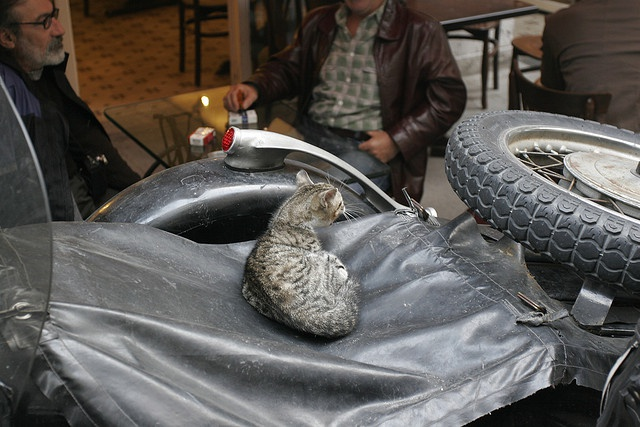Describe the objects in this image and their specific colors. I can see people in black and gray tones, motorcycle in black, gray, lightgray, and darkgray tones, people in black, maroon, and gray tones, cat in black, darkgray, and gray tones, and dining table in black, maroon, and olive tones in this image. 